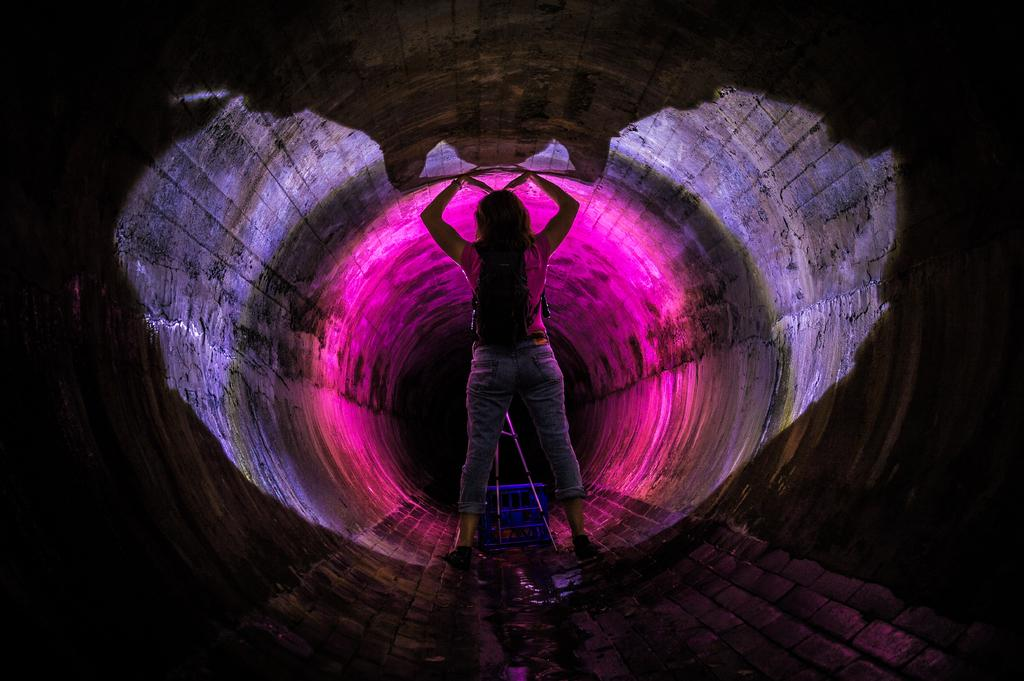Who or what is present in the image? There is a person in the image. Where is the person located? The person is standing inside a tunnel. What type of rice is being weighed on a scale in the image? There is no rice or scale present in the image; it only features a person standing inside a tunnel. 